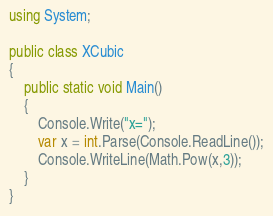<code> <loc_0><loc_0><loc_500><loc_500><_C#_>using System;

public class XCubic
{
	public static void Main()
	{
		Console.Write("x=");
		var x = int.Parse(Console.ReadLine());
		Console.WriteLine(Math.Pow(x,3));
	}
}</code> 